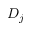<formula> <loc_0><loc_0><loc_500><loc_500>D _ { j }</formula> 